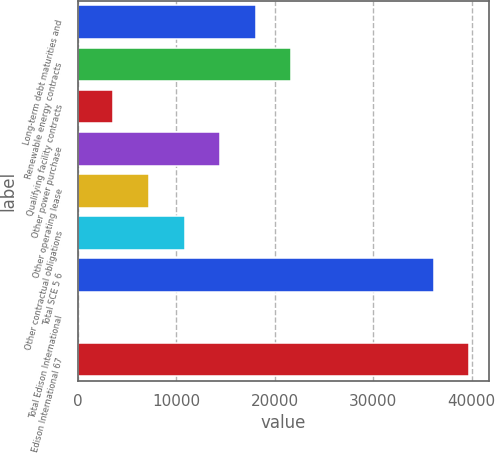Convert chart. <chart><loc_0><loc_0><loc_500><loc_500><bar_chart><fcel>Long-term debt maturities and<fcel>Renewable energy contracts<fcel>Qualifying facility contracts<fcel>Other power purchase<fcel>Other operating lease<fcel>Other contractual obligations<fcel>Total SCE 5 6<fcel>Total Edison International<fcel>Total Edison International 67<nl><fcel>18084<fcel>21700.4<fcel>3618.4<fcel>14467.6<fcel>7234.8<fcel>10851.2<fcel>36164<fcel>2<fcel>39780.4<nl></chart> 